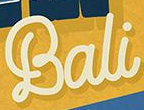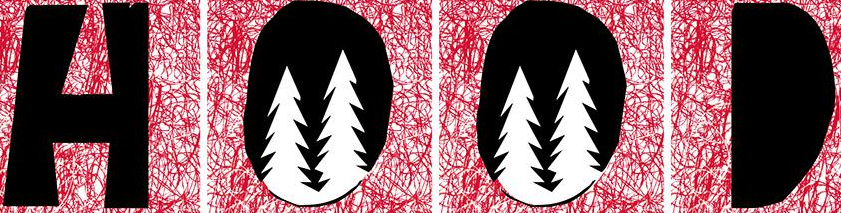What text appears in these images from left to right, separated by a semicolon? Bali; HOOD 